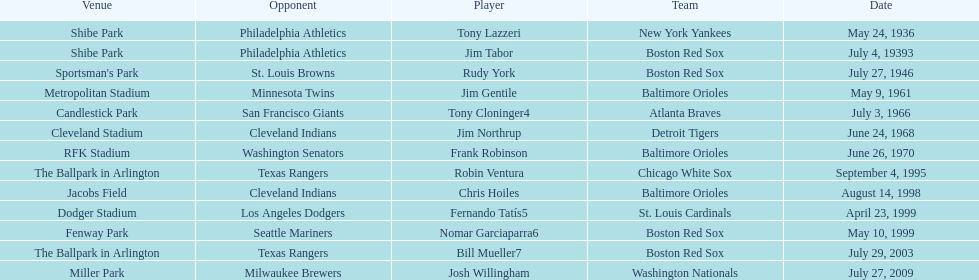What is the name of the player for the new york yankees in 1936? Tony Lazzeri. 